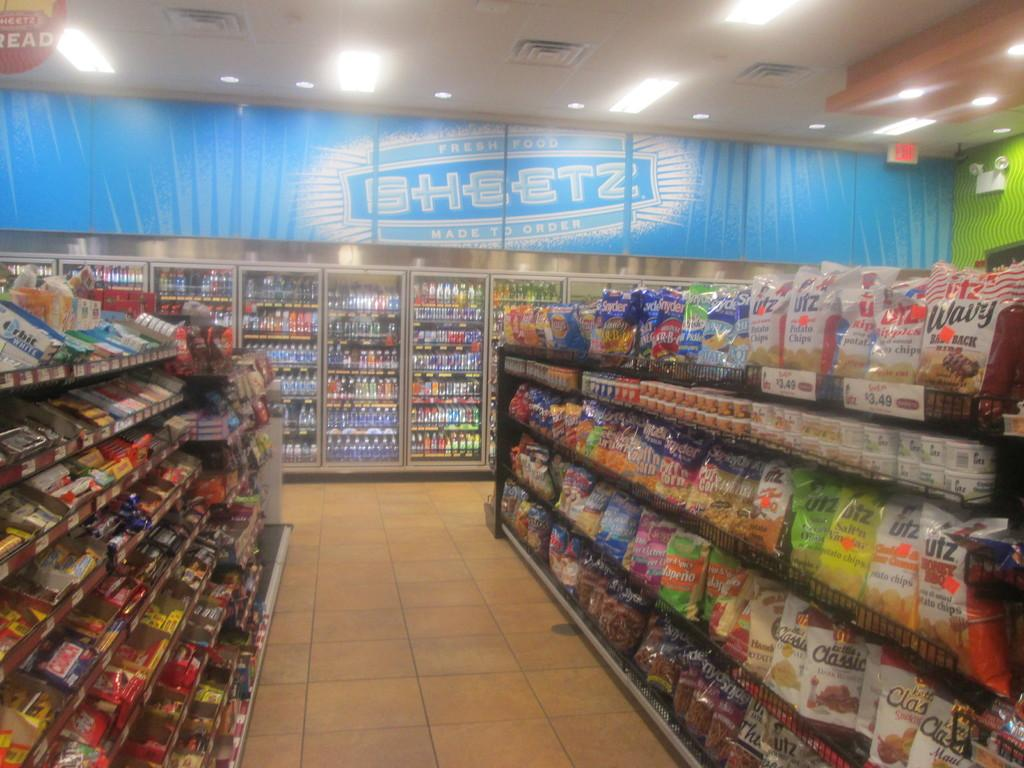<image>
Share a concise interpretation of the image provided. A large sign above coolers has the word sheetz on it. 